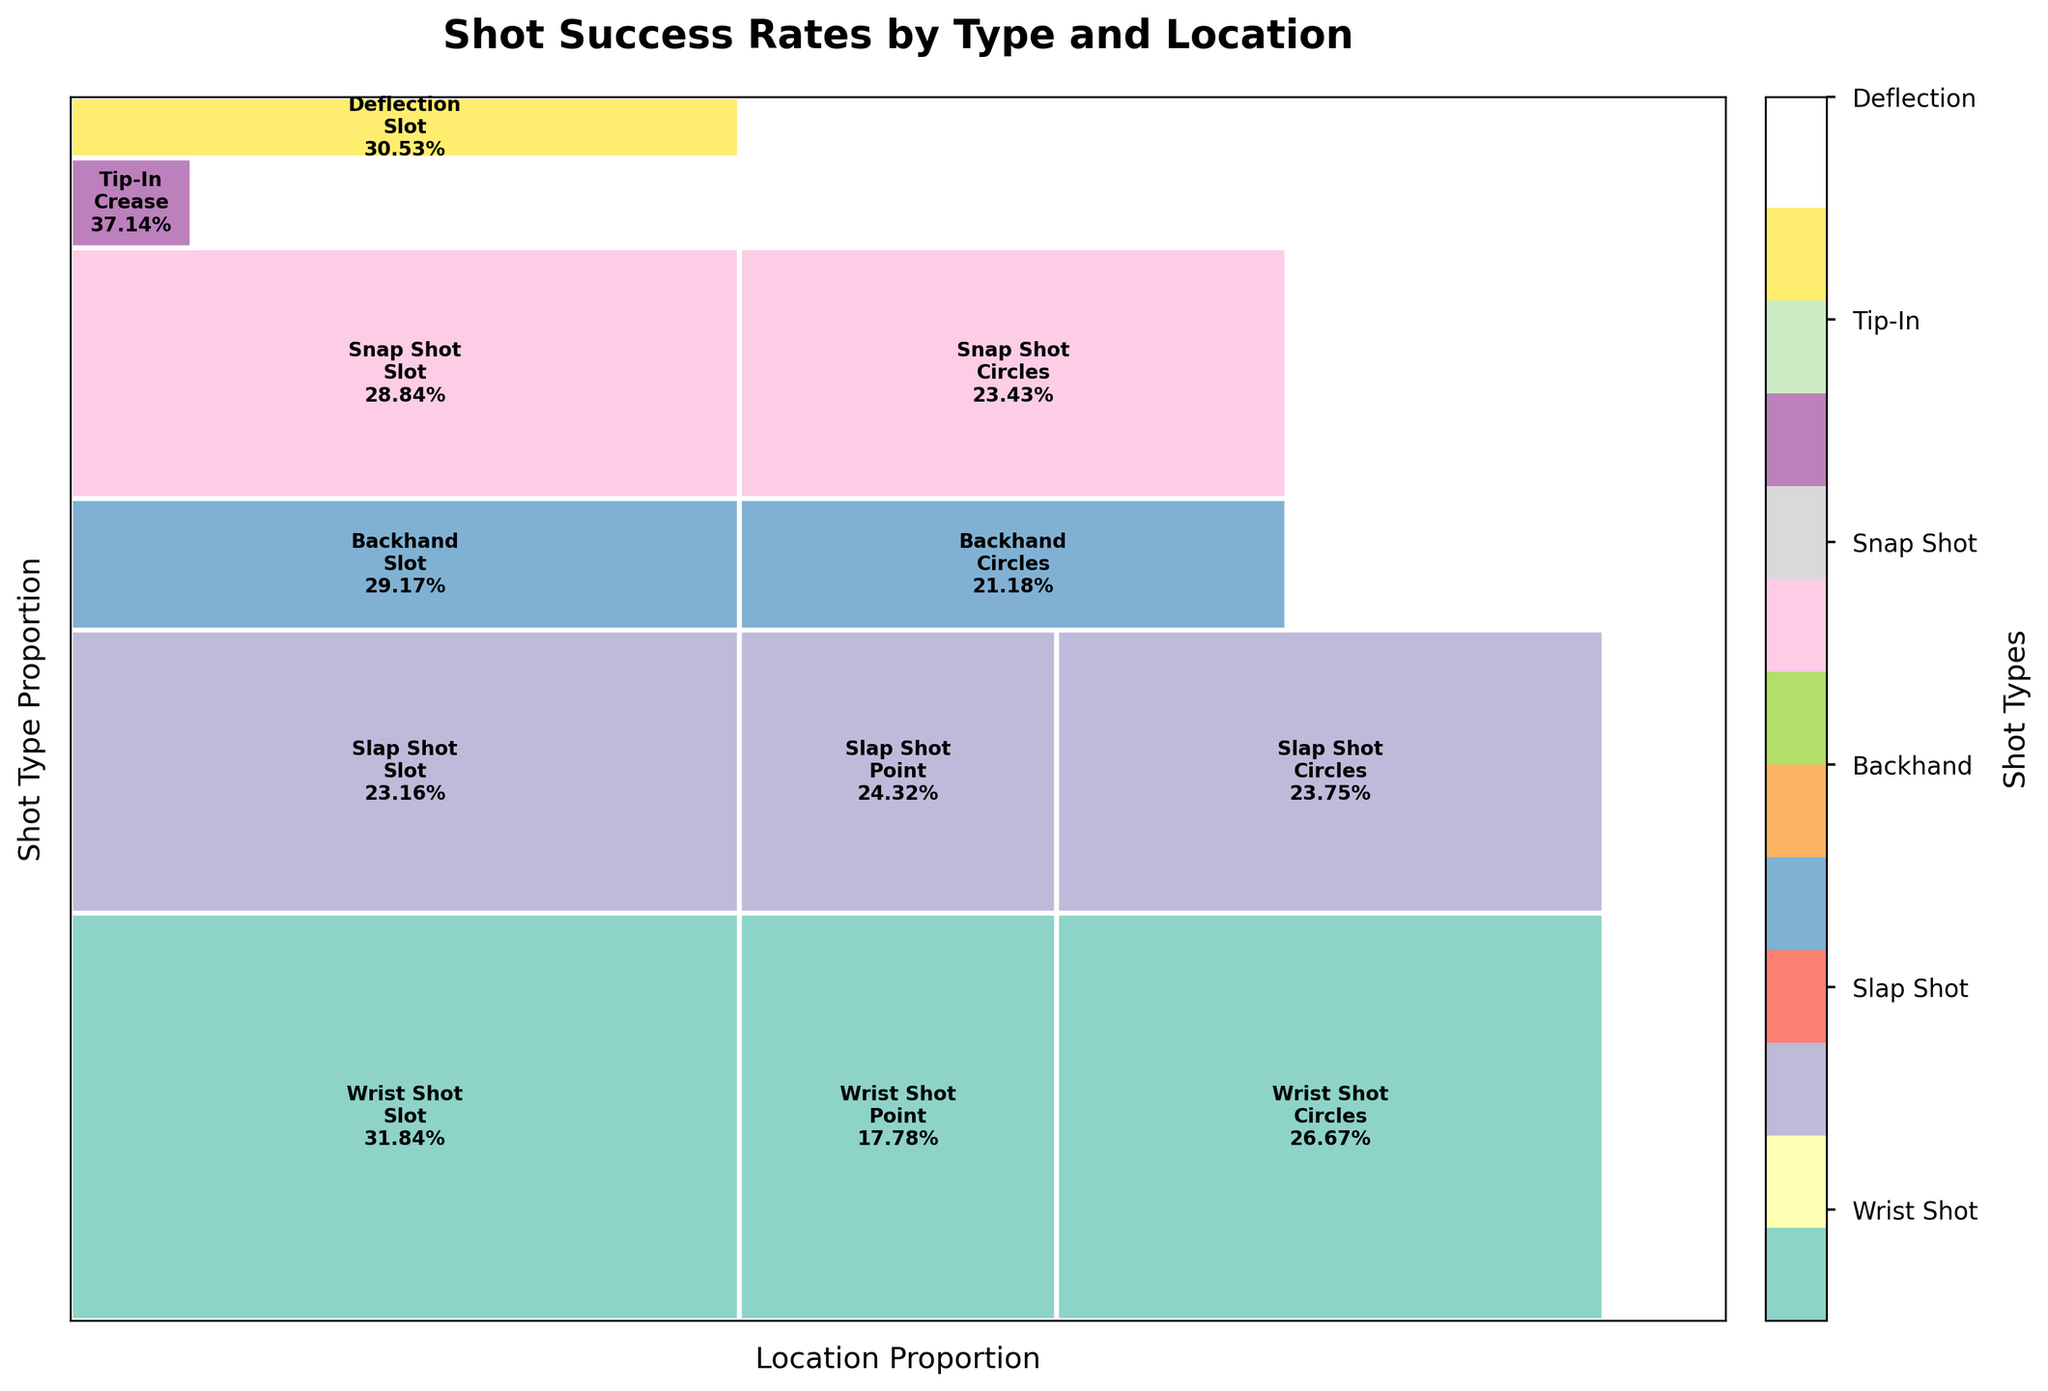Which shot type has the highest overall attempts? By examining the plot, we can observe the area corresponding to each shot type. The one with the largest total area reflects the highest overall attempts.
Answer: Wrist Shot What is the success rate of Wrist Shots from the Slot? The figure contains text annotations within each rectangle, showing success rates. Find the Wrist Shot in the Slot rectangle, where the text indicates 31.84%.
Answer: 31.84% How does the success rate of Slap Shots from the Point compare to that from the Circles? Look for the success rates in the text annotations within the Slap Shot sections under Point (24.32%) and Circles (23.75%). Compare these values to conclude that the Point has a slightly higher success rate.
Answer: Point has a higher success rate Which section (shot type and location) has the highest success rate? Check the annotated success rates within each rectangle and identify the highest percentage shown.
Answer: Tip-In from the Crease What is the total proportion of attempted Backhand shots? Find the rectangle areas associated with Backhand shots, add their heights together to get the overall proportion. It appears to be relatively smaller compared to others.
Answer: Approximately 14% Can you compare the success rates of Snap Shots in the Slot and Circles? Which one is better? Locate the Snap Shot sections and compare the annotations for success rates (Slot: 28.84%, Circles: 23.43%). The Slot has a higher rate.
Answer: Slot is better What proportion of attacks come from within the Slot area for all shot types? Sum up the widths of all Slot sections across different shot types to find the total proportion dedicated to Slot shots. Visually, this is a significant fraction of the plot.
Answer: Approximately 35% Which shot type has the smallest success rate, and at which location does this occur? Identify the lowest percentage annotation within the plot. This is likely Slap Shots from Slot (23.16%).
Answer: Slap Shot from Slot 